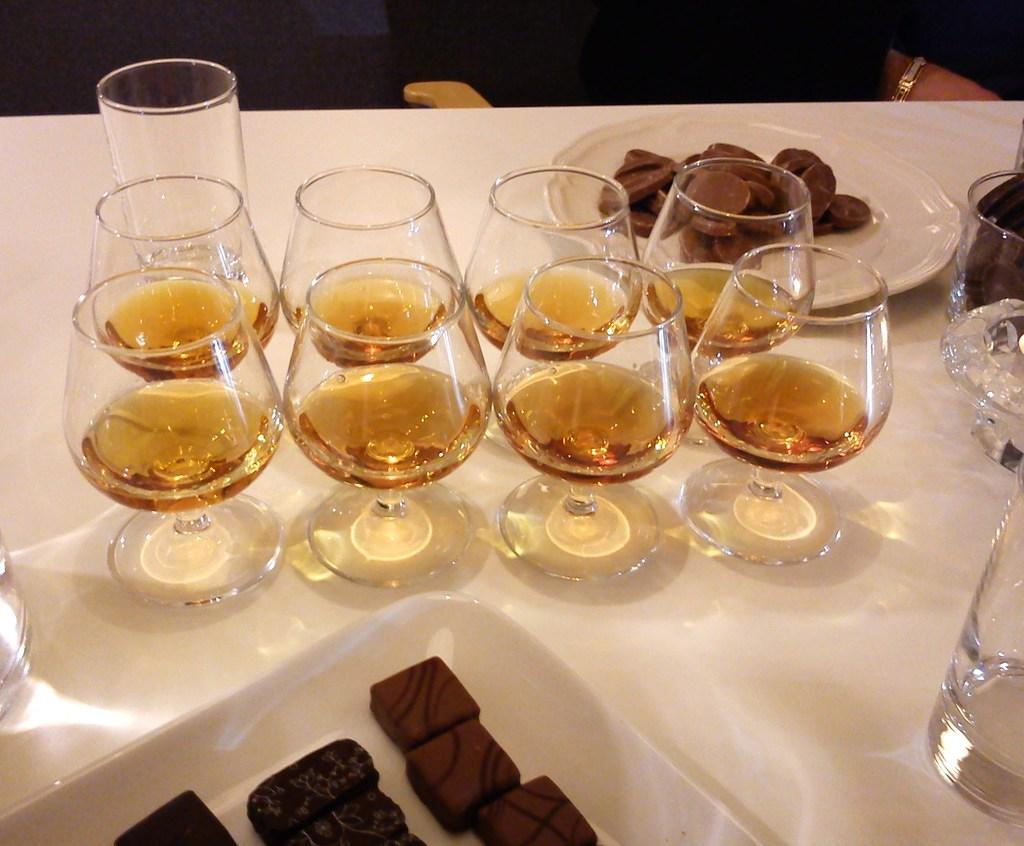What type of objects can be seen in the image? There are glasses, food items on a white color plate, and a tray in the image. What is the color of the plate that holds the food items? The plate is white. Are there any other objects visible on the table? Yes, there are other objects on a white color table in the image. What type of bushes can be seen in the image? There are no bushes present in the image. Is the scene in the image taking place during winter? The provided facts do not mention any seasonal context, so it cannot be determined if the scene is taking place during winter. 